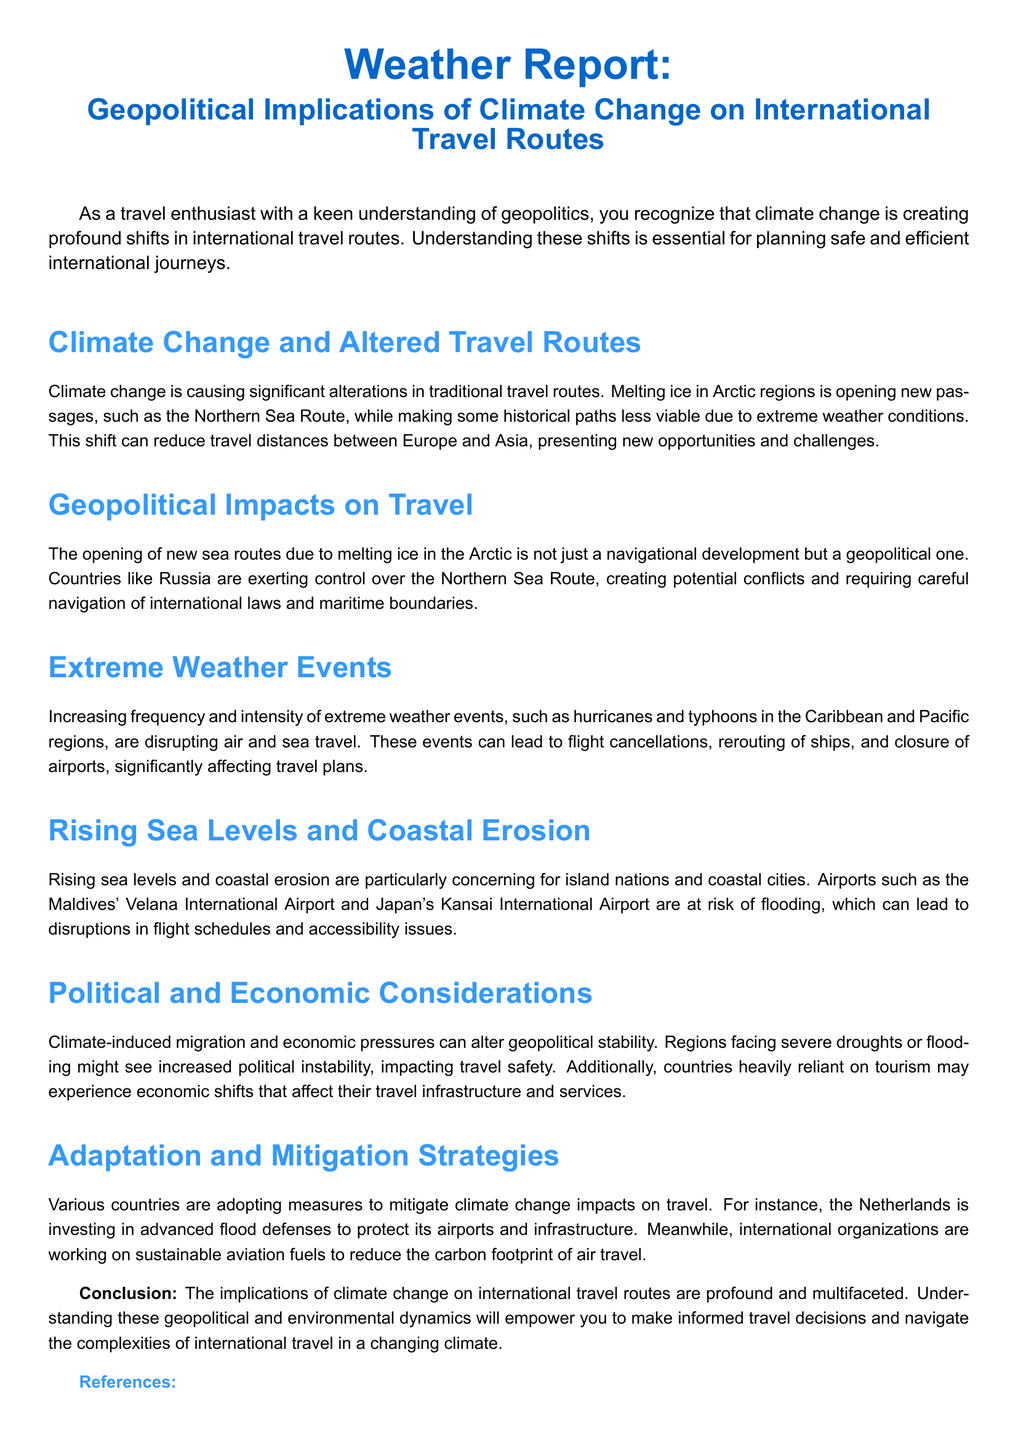What is the title of the report? The title of the report is mentioned at the beginning and summarizes its focus on climate change and travel routes.
Answer: Weather Report: Geopolitical Implications of Climate Change on International Travel Routes Which sea route is being affected by climate change? The document specifically references the Northern Sea Route affected by climate change.
Answer: Northern Sea Route What are two factors mentioned that can disrupt travel plans? The document lists extreme weather events and rising sea levels as factors disrupting travel.
Answer: Extreme weather events, rising sea levels Which country's airport is noted to be at risk of flooding? The report mentions specific airports at risk, including the Maldives' Velana International Airport.
Answer: Velana International Airport What is one adaptation strategy mentioned for protecting airports? The document details the Netherlands' investment in advanced flood defenses.
Answer: Advanced flood defenses How does climate change impact political stability? Increased political instability is linked to climate-induced migration and economic pressures according to the document.
Answer: Increased political instability What is one environmental challenge noted for island nations? Rising sea levels are highlighted as an environmental challenge for island nations.
Answer: Rising sea levels Which two organizations are working on sustainable aviation fuels? The document references international organizations but does not specify names, prompting reasoning about their involvement.
Answer: International organizations How does melting ice in the Arctic affect travel distances? Melting ice allows reduced travel distances between Europe and Asia due to new passages opening up.
Answer: Reduced travel distances 